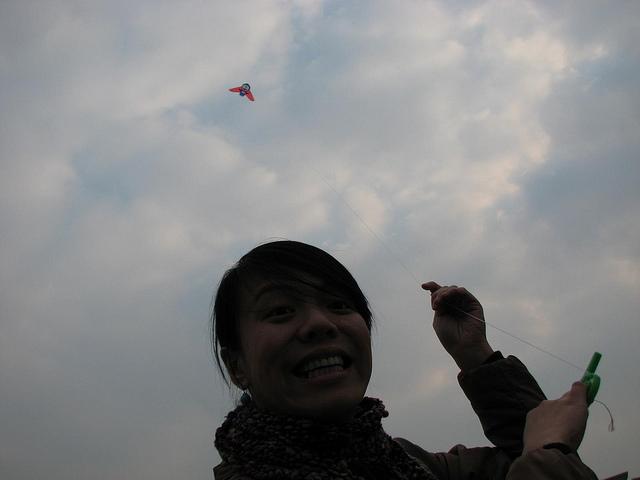What color is she?
Write a very short answer. Tan. Is the sky clear?
Give a very brief answer. No. What gender is the person with the kite?
Write a very short answer. Female. What activity does she seem to be in the middle of?
Write a very short answer. Flying kite. Is an aircraft visible?
Concise answer only. No. 